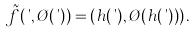Convert formula to latex. <formula><loc_0><loc_0><loc_500><loc_500>\tilde { f } ( \theta , \chi ( \theta ) ) = ( h ( \theta ) , \chi ( h ( \theta ) ) ) \, .</formula> 